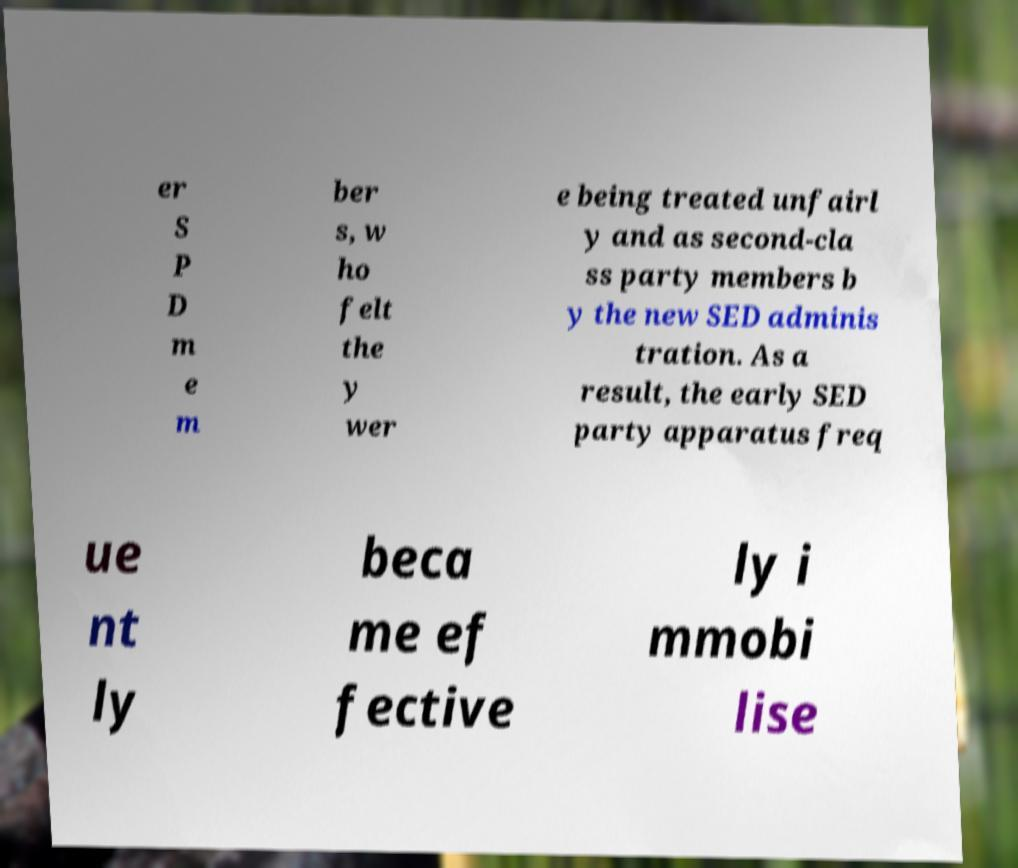For documentation purposes, I need the text within this image transcribed. Could you provide that? er S P D m e m ber s, w ho felt the y wer e being treated unfairl y and as second-cla ss party members b y the new SED adminis tration. As a result, the early SED party apparatus freq ue nt ly beca me ef fective ly i mmobi lise 